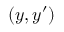<formula> <loc_0><loc_0><loc_500><loc_500>( y , y ^ { \prime } )</formula> 